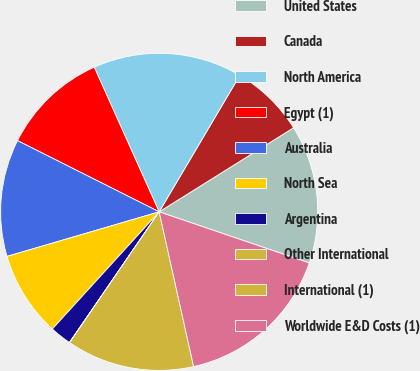<chart> <loc_0><loc_0><loc_500><loc_500><pie_chart><fcel>United States<fcel>Canada<fcel>North America<fcel>Egypt (1)<fcel>Australia<fcel>North Sea<fcel>Argentina<fcel>Other International<fcel>International (1)<fcel>Worldwide E&D Costs (1)<nl><fcel>14.12%<fcel>7.61%<fcel>15.21%<fcel>10.87%<fcel>11.95%<fcel>8.7%<fcel>2.19%<fcel>0.02%<fcel>13.04%<fcel>16.29%<nl></chart> 